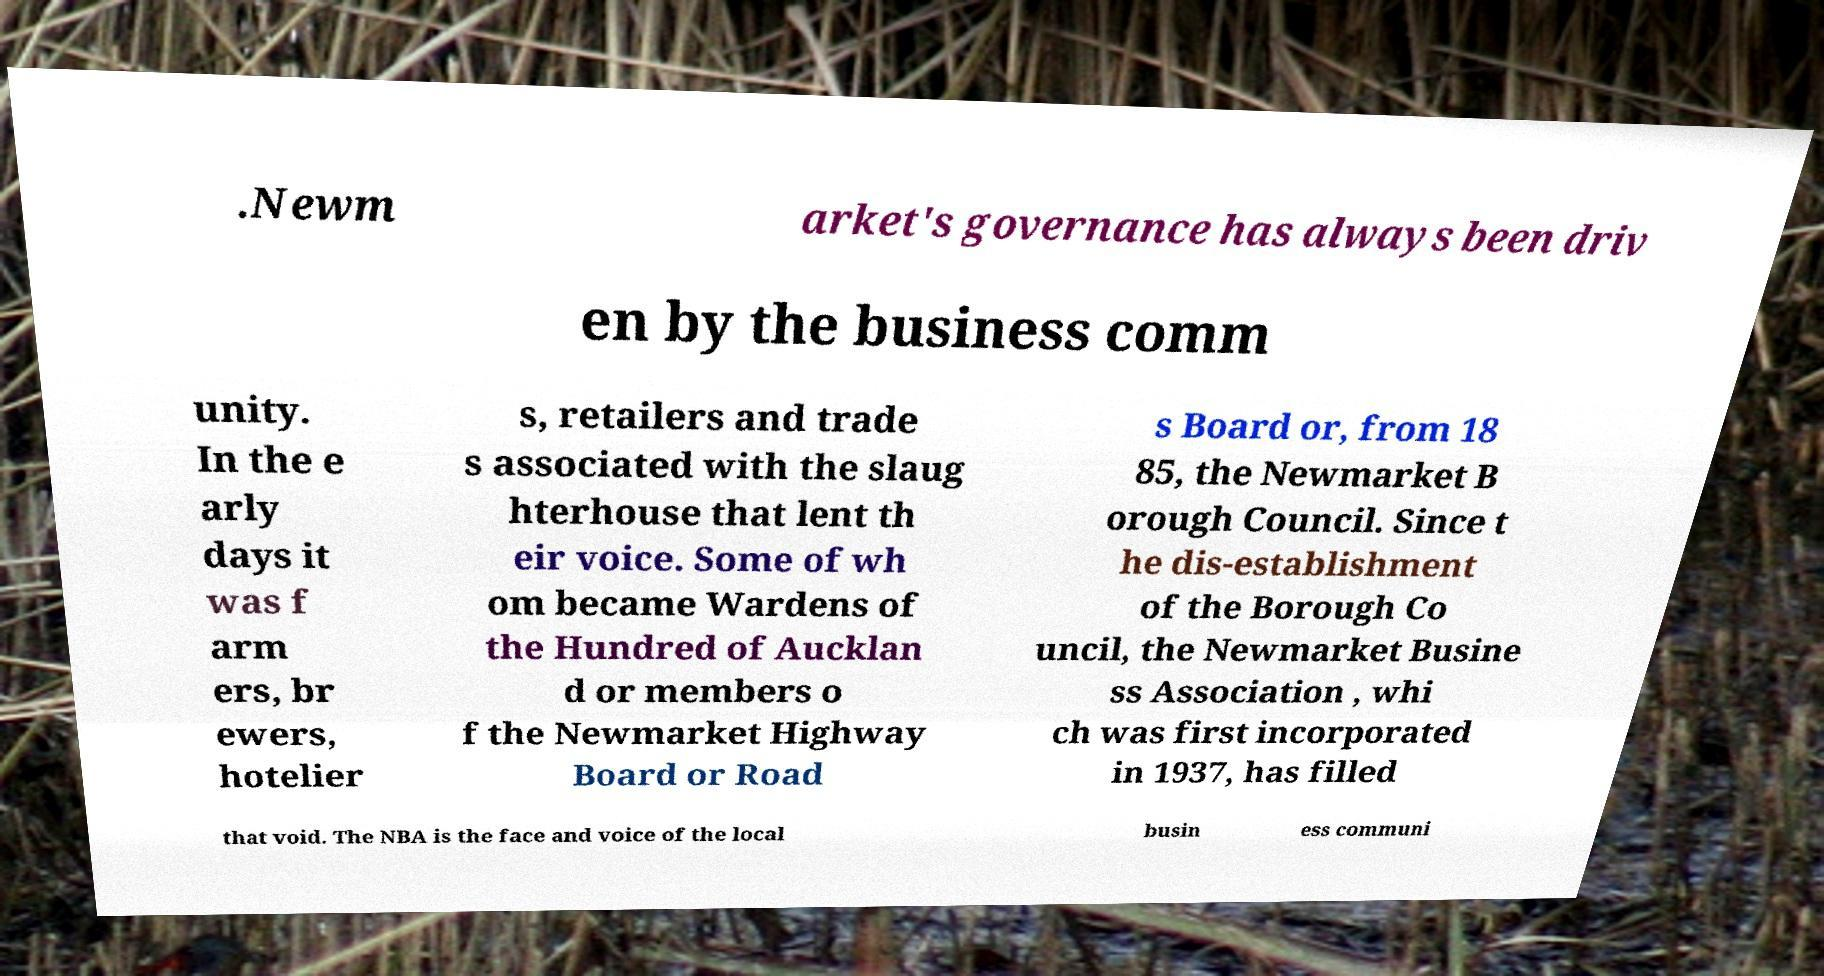I need the written content from this picture converted into text. Can you do that? .Newm arket's governance has always been driv en by the business comm unity. In the e arly days it was f arm ers, br ewers, hotelier s, retailers and trade s associated with the slaug hterhouse that lent th eir voice. Some of wh om became Wardens of the Hundred of Aucklan d or members o f the Newmarket Highway Board or Road s Board or, from 18 85, the Newmarket B orough Council. Since t he dis-establishment of the Borough Co uncil, the Newmarket Busine ss Association , whi ch was first incorporated in 1937, has filled that void. The NBA is the face and voice of the local busin ess communi 